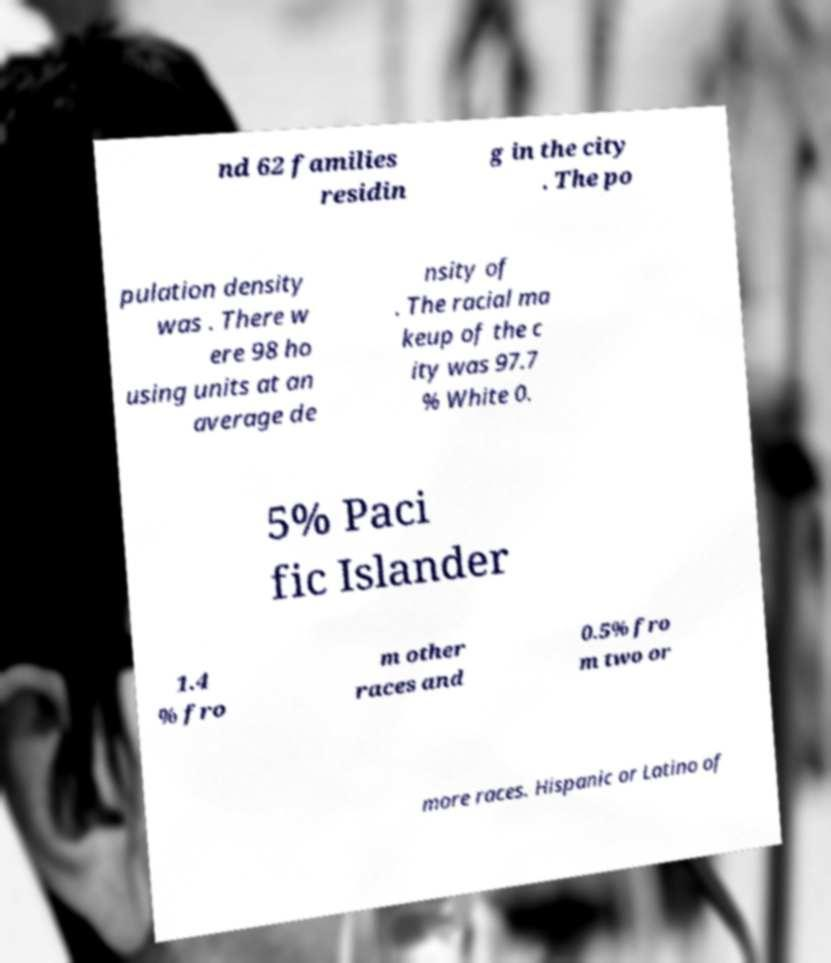Could you extract and type out the text from this image? nd 62 families residin g in the city . The po pulation density was . There w ere 98 ho using units at an average de nsity of . The racial ma keup of the c ity was 97.7 % White 0. 5% Paci fic Islander 1.4 % fro m other races and 0.5% fro m two or more races. Hispanic or Latino of 